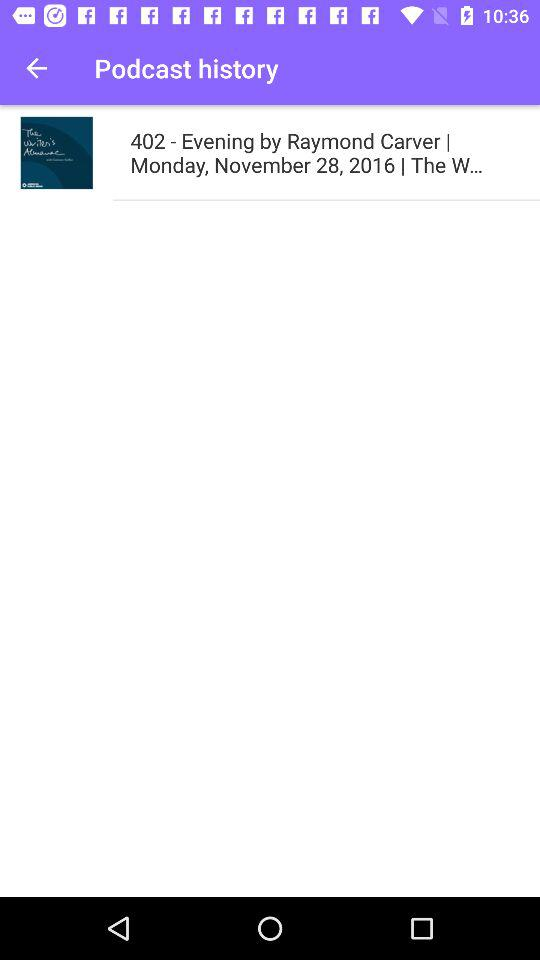What is the date of "402 - Evening by Raymond Carver"? The date is Monday, November 28, 2016. 